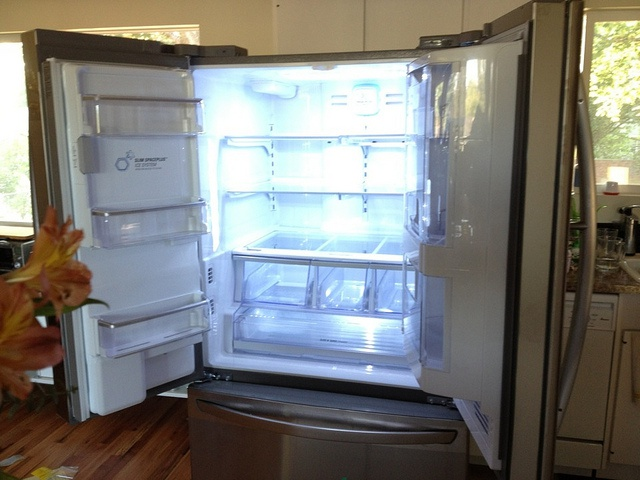Describe the objects in this image and their specific colors. I can see refrigerator in olive, black, gray, white, and darkgray tones, potted plant in olive, maroon, black, and gray tones, cup in olive, black, and gray tones, and cup in black and olive tones in this image. 